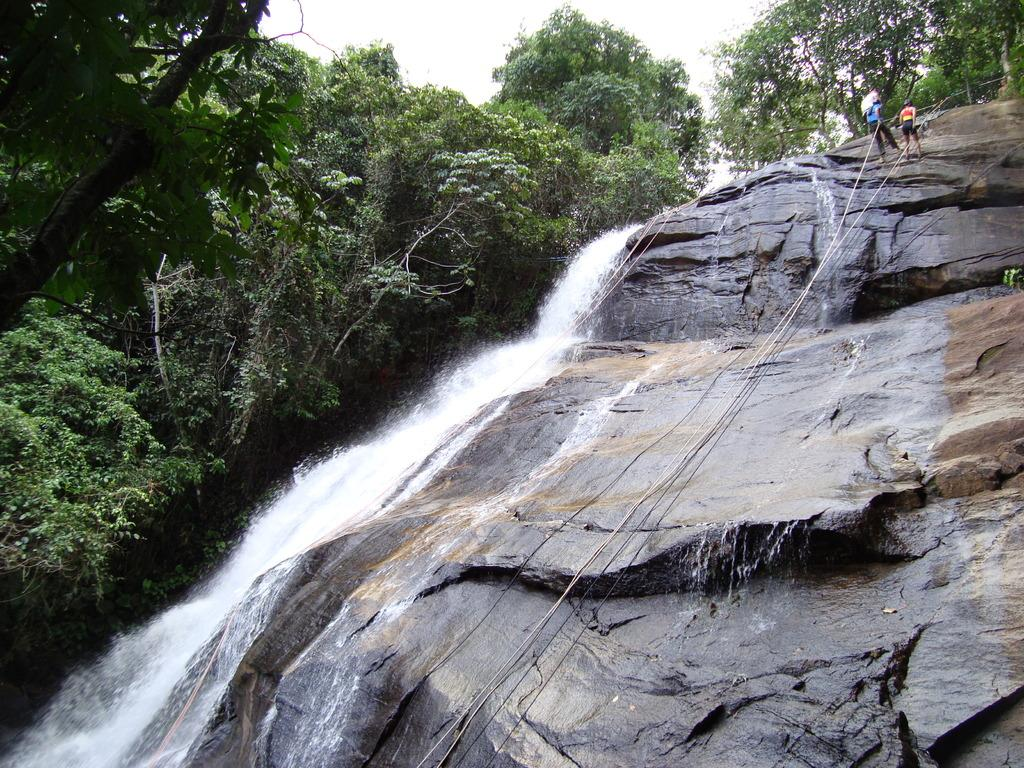What natural feature is the main subject of the image? There is a waterfall in the image. What type of vegetation is present in the image? There are trees in the image. What activity are the people engaged in? The people are climbing a rock. How are the people assisting themselves in their climb? The people are using a rope to assist in their climb. What type of print can be seen on the cow in the image? There is no cow present in the image, so no print can be seen. What type of cord is being used by the people to climb the rock? The provided facts do not mention a cord; the people are using a rope to assist in their climb. 